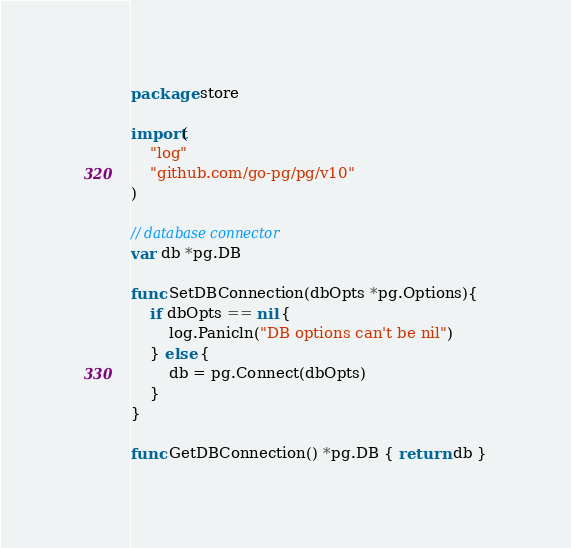Convert code to text. <code><loc_0><loc_0><loc_500><loc_500><_Go_>package store

import(
	"log"
	"github.com/go-pg/pg/v10"
)

// database connector
var db *pg.DB

func SetDBConnection(dbOpts *pg.Options){
	if dbOpts == nil {
		log.Panicln("DB options can't be nil")
	} else {
		db = pg.Connect(dbOpts)
	}
}

func GetDBConnection() *pg.DB { return db }</code> 